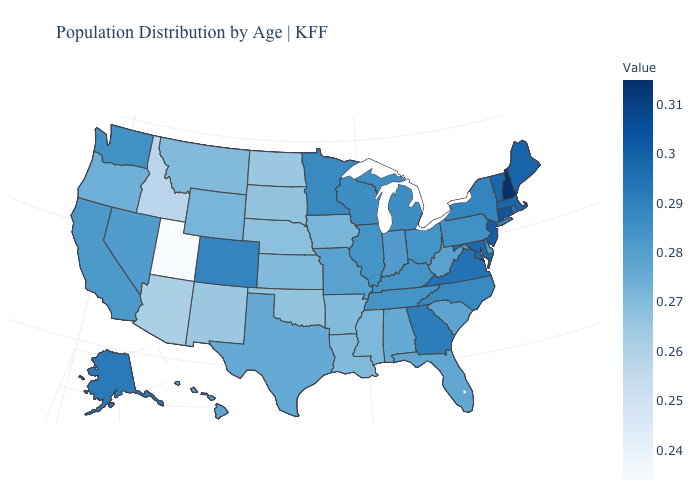Among the states that border California , which have the highest value?
Quick response, please. Nevada. Among the states that border Michigan , which have the lowest value?
Short answer required. Indiana. Does Kentucky have the highest value in the USA?
Quick response, please. No. Is the legend a continuous bar?
Keep it brief. Yes. 